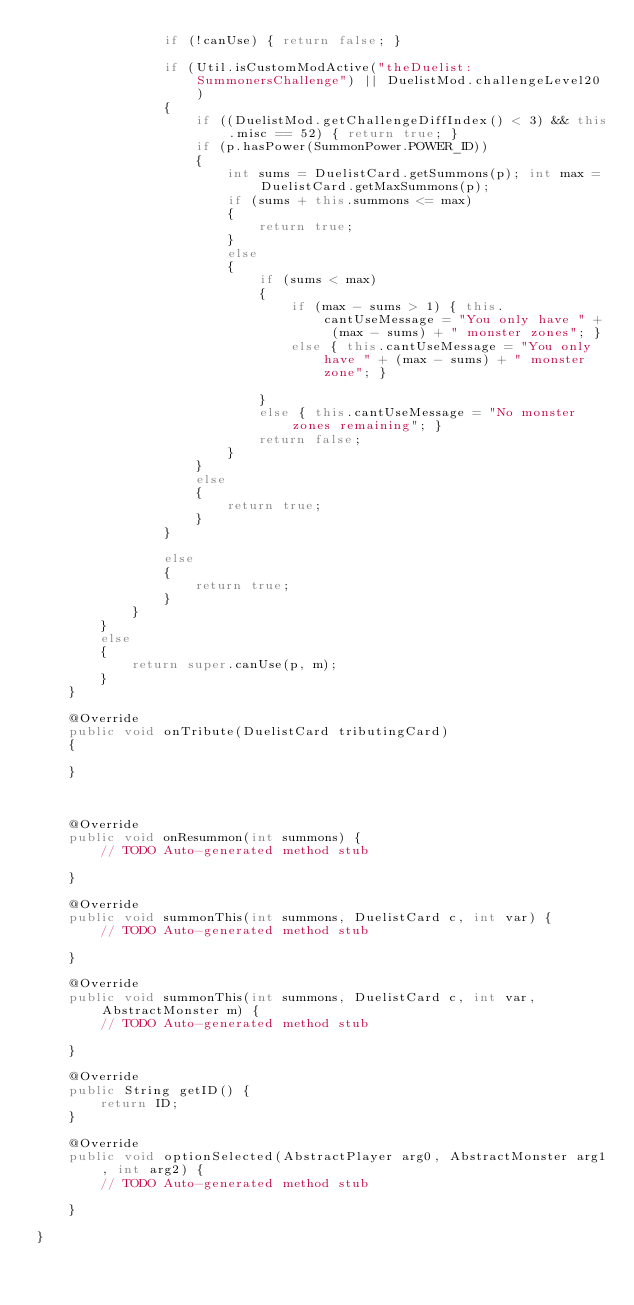<code> <loc_0><loc_0><loc_500><loc_500><_Java_>    	    	if (!canUse) { return false; }

    	    	if (Util.isCustomModActive("theDuelist:SummonersChallenge") || DuelistMod.challengeLevel20)
    	    	{
    	    		if ((DuelistMod.getChallengeDiffIndex() < 3) && this.misc == 52) { return true; }
    	    		if (p.hasPower(SummonPower.POWER_ID))
    	    		{
    	    			int sums = DuelistCard.getSummons(p); int max = DuelistCard.getMaxSummons(p);
    	    			if (sums + this.summons <= max) 
    	    			{ 
    	    				return true; 
    	    			}
    	    			else 
    	    			{ 
    	    				if (sums < max) 
    	    				{ 
    	    					if (max - sums > 1) { this.cantUseMessage = "You only have " + (max - sums) + " monster zones"; }
    	    					else { this.cantUseMessage = "You only have " + (max - sums) + " monster zone"; }
    	    					
    	    				}
    	    				else { this.cantUseMessage = "No monster zones remaining"; }
    	    				return false; 
    	    			}
    	    		}
    	    		else
    	    		{
    	    			return true;
    	    		}
    	    	}
    	    	
    	    	else
    	    	{
    	    		return true;
    	    	}
    		}
    	}
    	else
    	{
    		return super.canUse(p, m);
    	}
    }

	@Override
	public void onTribute(DuelistCard tributingCard)
	{
		
	}

	

	@Override
	public void onResummon(int summons) {
		// TODO Auto-generated method stub
		
	}

	@Override
	public void summonThis(int summons, DuelistCard c, int var) {
		// TODO Auto-generated method stub
		
	}

	@Override
	public void summonThis(int summons, DuelistCard c, int var, AbstractMonster m) {
		// TODO Auto-generated method stub
		
	}

	@Override
	public String getID() {
		return ID;
	}

	@Override
	public void optionSelected(AbstractPlayer arg0, AbstractMonster arg1, int arg2) {
		// TODO Auto-generated method stub
		
	}
   
}</code> 